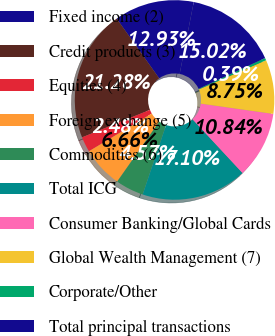Convert chart to OTSL. <chart><loc_0><loc_0><loc_500><loc_500><pie_chart><fcel>Fixed income (2)<fcel>Credit products (3)<fcel>Equities (4)<fcel>Foreign exchange (5)<fcel>Commodities (6)<fcel>Total ICG<fcel>Consumer Banking/Global Cards<fcel>Global Wealth Management (7)<fcel>Corporate/Other<fcel>Total principal transactions<nl><fcel>12.93%<fcel>21.28%<fcel>2.48%<fcel>6.66%<fcel>4.57%<fcel>17.1%<fcel>10.84%<fcel>8.75%<fcel>0.39%<fcel>15.02%<nl></chart> 